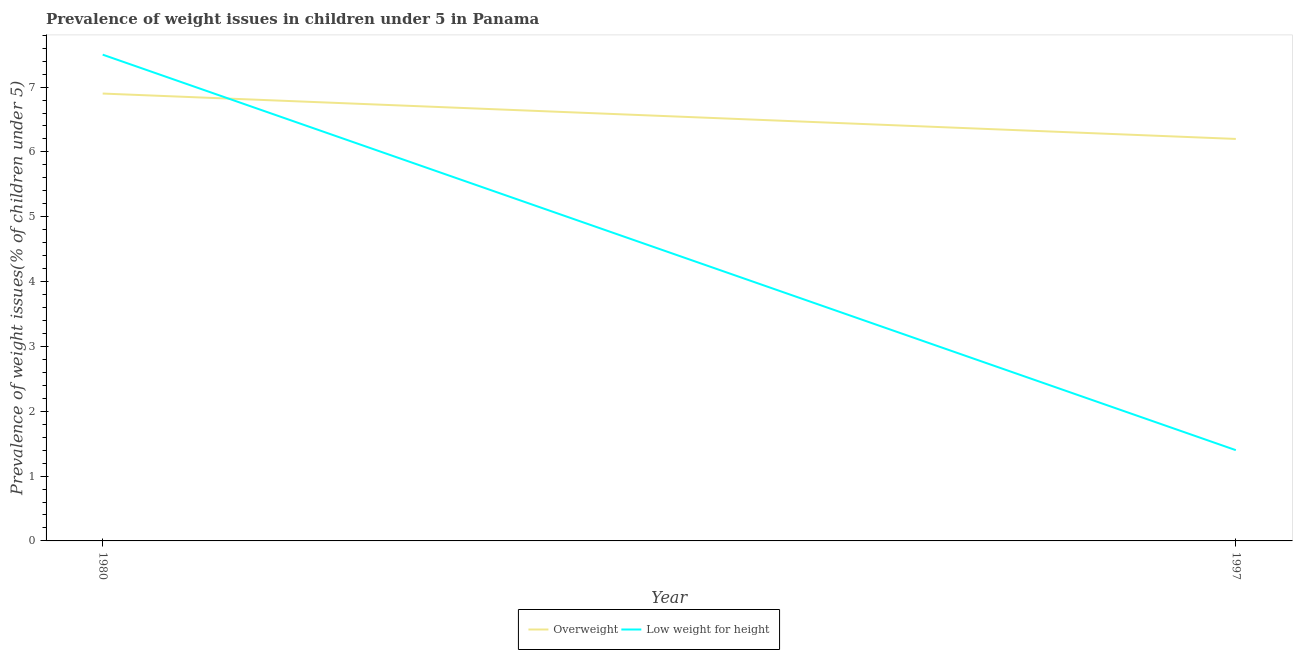Across all years, what is the maximum percentage of overweight children?
Your answer should be very brief. 6.9. Across all years, what is the minimum percentage of underweight children?
Give a very brief answer. 1.4. What is the total percentage of overweight children in the graph?
Offer a terse response. 13.1. What is the difference between the percentage of underweight children in 1980 and that in 1997?
Give a very brief answer. 6.1. What is the difference between the percentage of overweight children in 1980 and the percentage of underweight children in 1997?
Offer a terse response. 5.5. What is the average percentage of overweight children per year?
Your answer should be very brief. 6.55. In the year 1980, what is the difference between the percentage of underweight children and percentage of overweight children?
Provide a succinct answer. 0.6. In how many years, is the percentage of underweight children greater than 5.2 %?
Ensure brevity in your answer.  1. What is the ratio of the percentage of overweight children in 1980 to that in 1997?
Keep it short and to the point. 1.11. Does the percentage of overweight children monotonically increase over the years?
Ensure brevity in your answer.  No. Is the percentage of overweight children strictly less than the percentage of underweight children over the years?
Your answer should be compact. No. How many lines are there?
Your answer should be compact. 2. What is the difference between two consecutive major ticks on the Y-axis?
Provide a succinct answer. 1. Are the values on the major ticks of Y-axis written in scientific E-notation?
Your response must be concise. No. Does the graph contain any zero values?
Provide a short and direct response. No. How are the legend labels stacked?
Your response must be concise. Horizontal. What is the title of the graph?
Offer a very short reply. Prevalence of weight issues in children under 5 in Panama. Does "Urban Population" appear as one of the legend labels in the graph?
Ensure brevity in your answer.  No. What is the label or title of the Y-axis?
Offer a terse response. Prevalence of weight issues(% of children under 5). What is the Prevalence of weight issues(% of children under 5) of Overweight in 1980?
Give a very brief answer. 6.9. What is the Prevalence of weight issues(% of children under 5) of Overweight in 1997?
Keep it short and to the point. 6.2. What is the Prevalence of weight issues(% of children under 5) of Low weight for height in 1997?
Provide a short and direct response. 1.4. Across all years, what is the maximum Prevalence of weight issues(% of children under 5) in Overweight?
Make the answer very short. 6.9. Across all years, what is the maximum Prevalence of weight issues(% of children under 5) of Low weight for height?
Offer a terse response. 7.5. Across all years, what is the minimum Prevalence of weight issues(% of children under 5) in Overweight?
Offer a terse response. 6.2. Across all years, what is the minimum Prevalence of weight issues(% of children under 5) in Low weight for height?
Keep it short and to the point. 1.4. What is the total Prevalence of weight issues(% of children under 5) of Low weight for height in the graph?
Give a very brief answer. 8.9. What is the difference between the Prevalence of weight issues(% of children under 5) in Overweight in 1980 and that in 1997?
Ensure brevity in your answer.  0.7. What is the difference between the Prevalence of weight issues(% of children under 5) in Overweight in 1980 and the Prevalence of weight issues(% of children under 5) in Low weight for height in 1997?
Keep it short and to the point. 5.5. What is the average Prevalence of weight issues(% of children under 5) in Overweight per year?
Make the answer very short. 6.55. What is the average Prevalence of weight issues(% of children under 5) in Low weight for height per year?
Give a very brief answer. 4.45. What is the ratio of the Prevalence of weight issues(% of children under 5) of Overweight in 1980 to that in 1997?
Give a very brief answer. 1.11. What is the ratio of the Prevalence of weight issues(% of children under 5) in Low weight for height in 1980 to that in 1997?
Your answer should be compact. 5.36. What is the difference between the highest and the second highest Prevalence of weight issues(% of children under 5) in Overweight?
Keep it short and to the point. 0.7. What is the difference between the highest and the second highest Prevalence of weight issues(% of children under 5) in Low weight for height?
Offer a very short reply. 6.1. What is the difference between the highest and the lowest Prevalence of weight issues(% of children under 5) of Low weight for height?
Your answer should be compact. 6.1. 